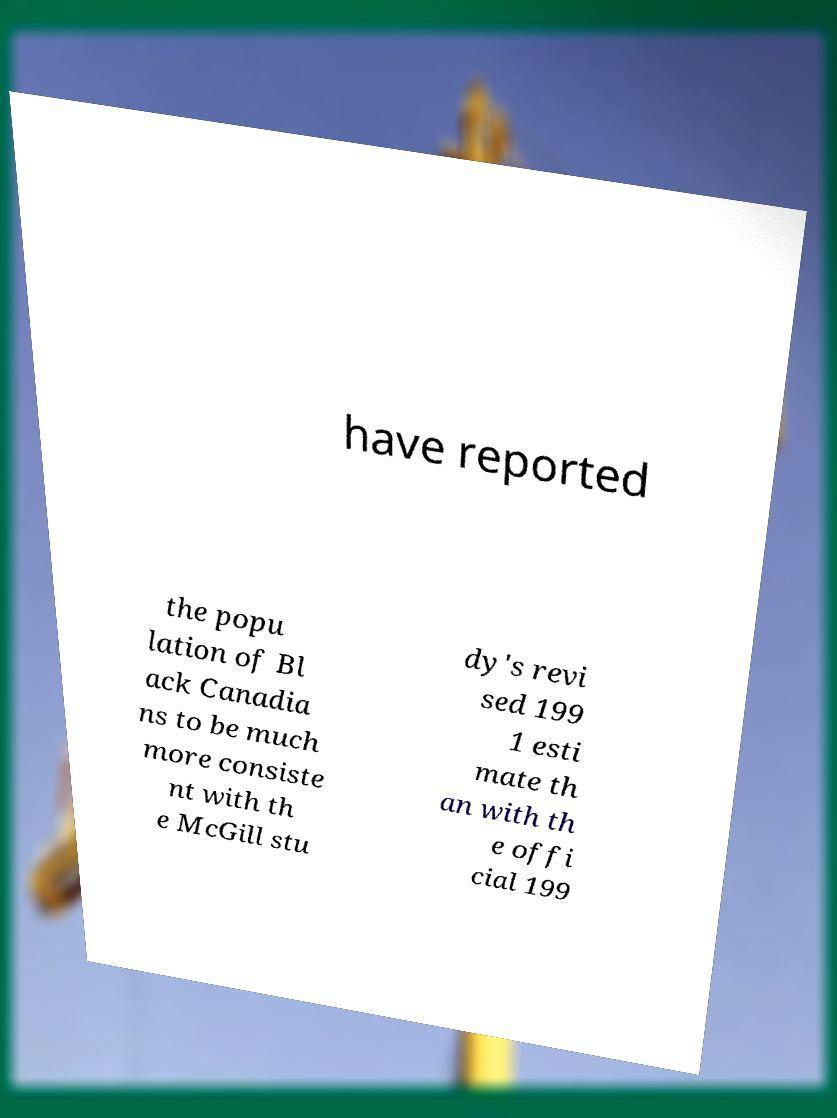Can you accurately transcribe the text from the provided image for me? have reported the popu lation of Bl ack Canadia ns to be much more consiste nt with th e McGill stu dy's revi sed 199 1 esti mate th an with th e offi cial 199 